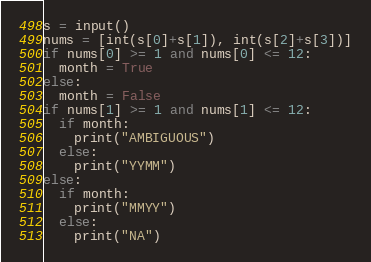Convert code to text. <code><loc_0><loc_0><loc_500><loc_500><_Python_>s = input()
nums = [int(s[0]+s[1]), int(s[2]+s[3])]
if nums[0] >= 1 and nums[0] <= 12:
  month = True
else:
  month = False
if nums[1] >= 1 and nums[1] <= 12:
  if month:
    print("AMBIGUOUS")
  else:
    print("YYMM")
else:
  if month:
    print("MMYY")
  else:
    print("NA")</code> 